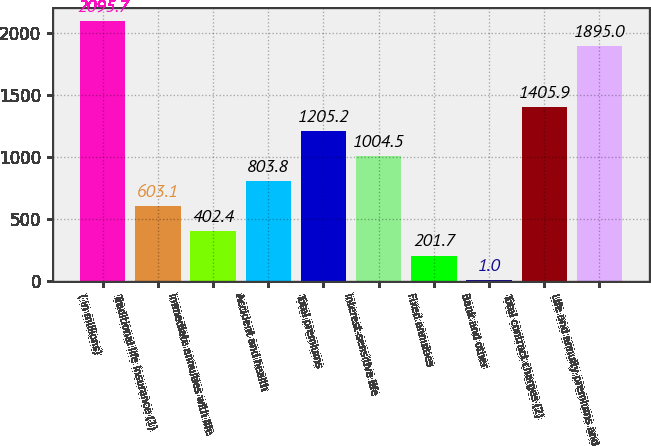<chart> <loc_0><loc_0><loc_500><loc_500><bar_chart><fcel>( in millions)<fcel>Traditional life insurance (1)<fcel>Immediate annuities with life<fcel>Accident and health<fcel>Total premiums<fcel>Interest-sensitive life<fcel>Fixed annuities<fcel>Bank and other<fcel>Total contract charges (2)<fcel>Life and annuity premiums and<nl><fcel>2095.7<fcel>603.1<fcel>402.4<fcel>803.8<fcel>1205.2<fcel>1004.5<fcel>201.7<fcel>1<fcel>1405.9<fcel>1895<nl></chart> 